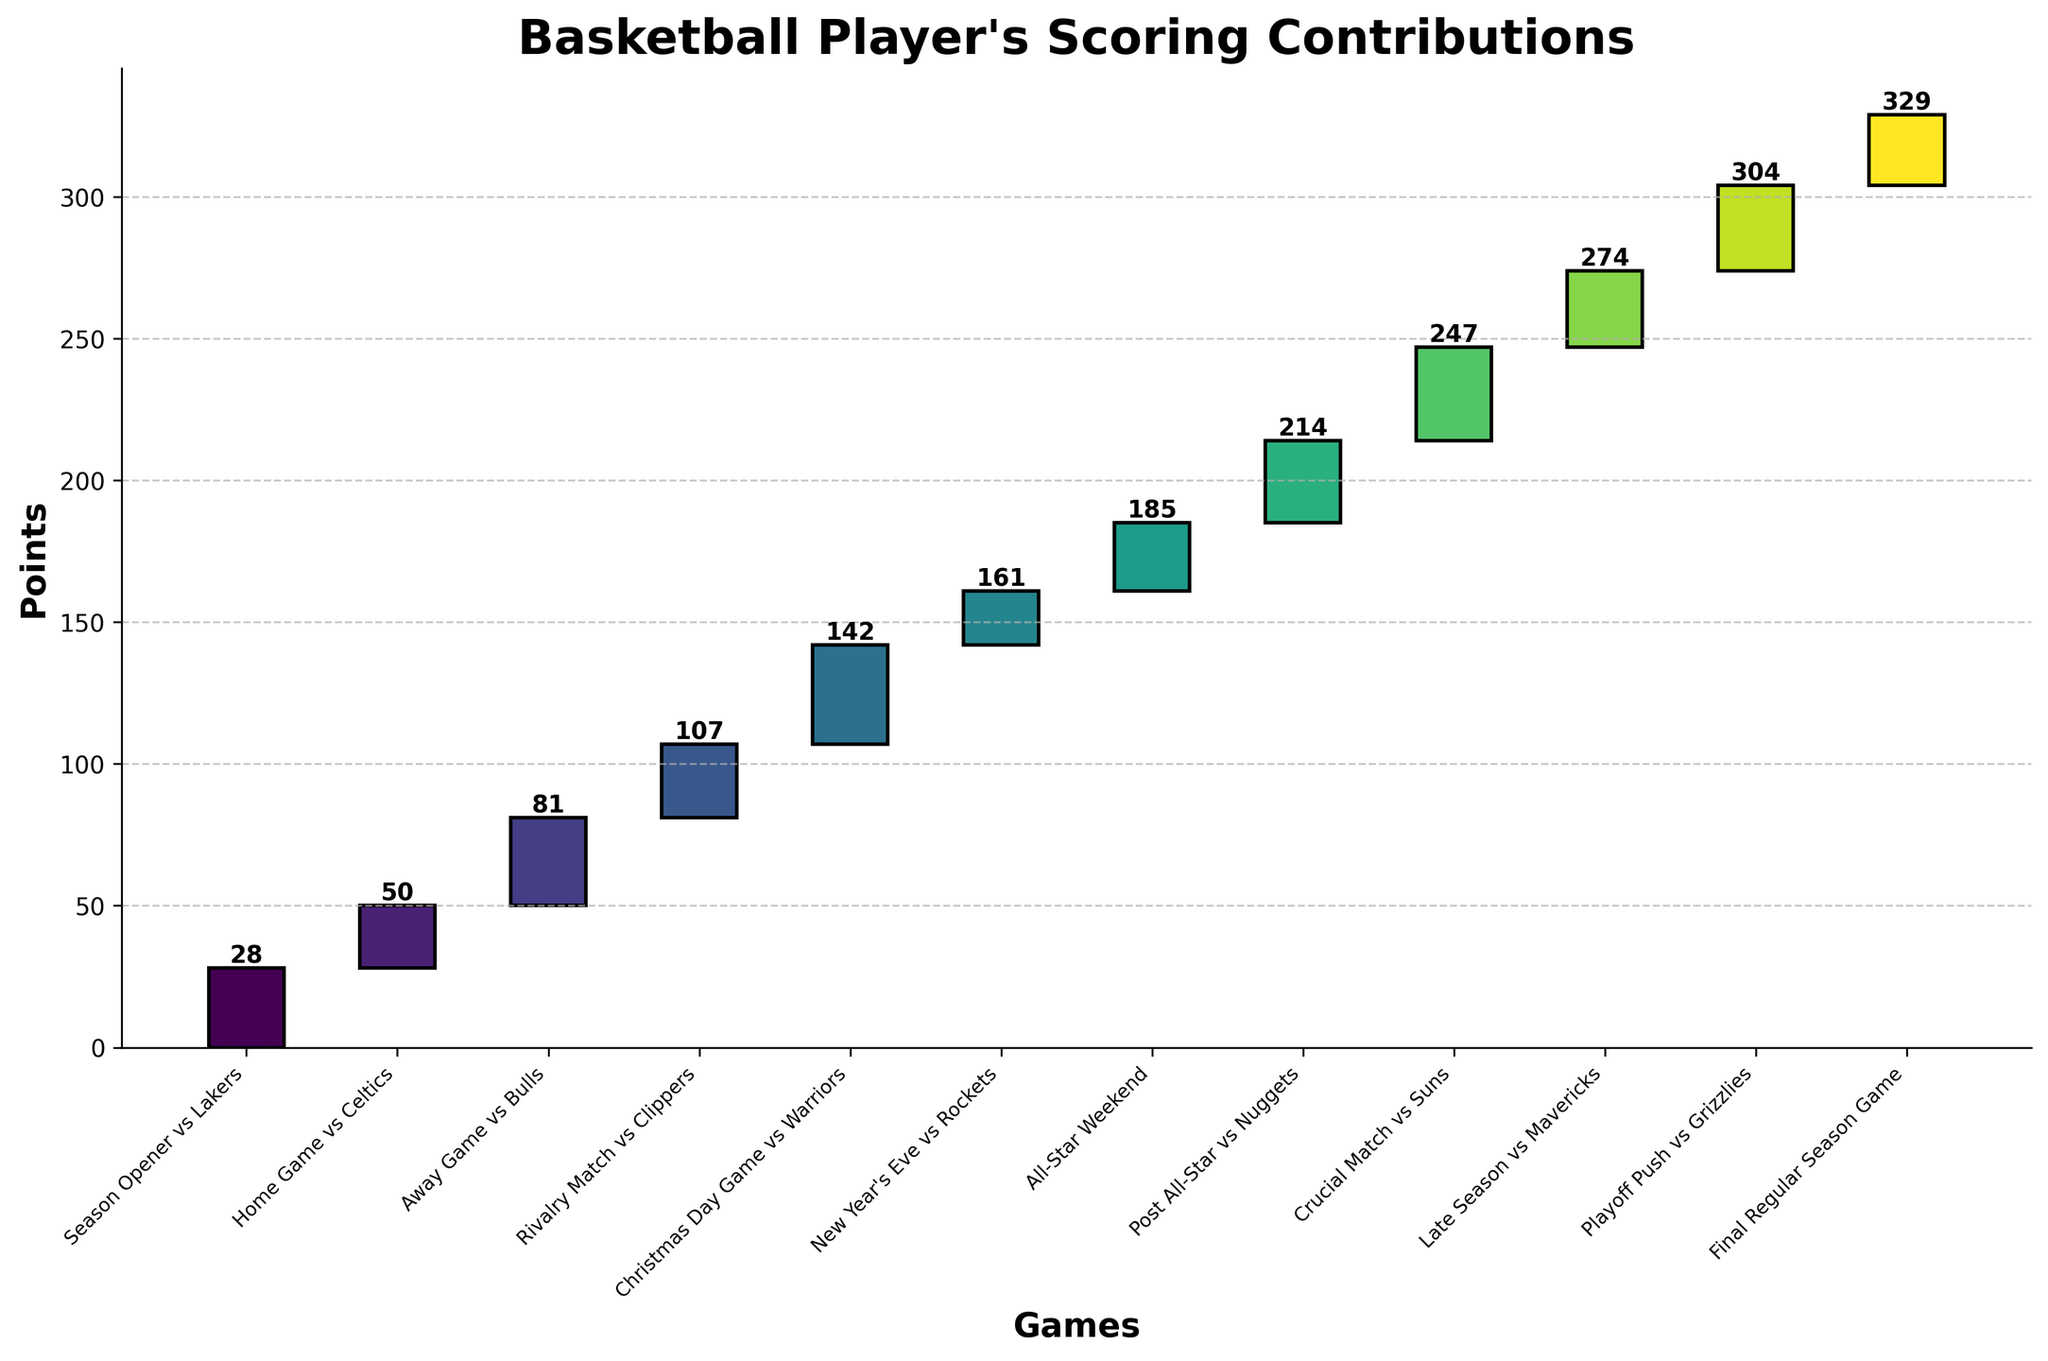What is the title of the chart? The title of the chart is displayed at the top in large, bold text. It sets the context for what the figure is representing.
Answer: Basketball Player's Scoring Contributions Which game had the highest point contribution? Look for the highest individual bar in the chart, which corresponds to the game with the highest point contribution.
Answer: Christmas Day Game vs Warriors How many total points were scored in the season opener? Check the bar and the text label at the very beginning of the chart, which represents the first game.
Answer: 28 What is the total running score after the game against the Mavericks? Identify the running total on the chart after the bar corresponding to the game against the Mavericks.
Answer: 274 Which game immediately followed the All-Star Weekend? Look at the order of games along the x-axis and find the game that comes right after the All-Star Weekend.
Answer: Post All-Star vs Nuggets What was the average points scored per game during the first three games? Sum the points of the first three games and divide by three. (28 + 22 + 31) / 3 = 81 / 3
Answer: 27 Which game had fewer points than the game against the Suns but more than the game vs Rockets? Compare the heights of the bars and find the game that falls between the Suns and Rockets games in terms of points scored.
Answer: Late Season vs Mavericks What is the cumulative point total before the team reached the Post All-Star game? Look at the running total right before the bar for the Post All-Star game.
Answer: 185 How many games had a point total of at least 30? Count all the bars in the chart that reach or exceed a height of 30 points.
Answer: 4 